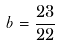<formula> <loc_0><loc_0><loc_500><loc_500>b = { \frac { 2 3 } { 2 2 } }</formula> 